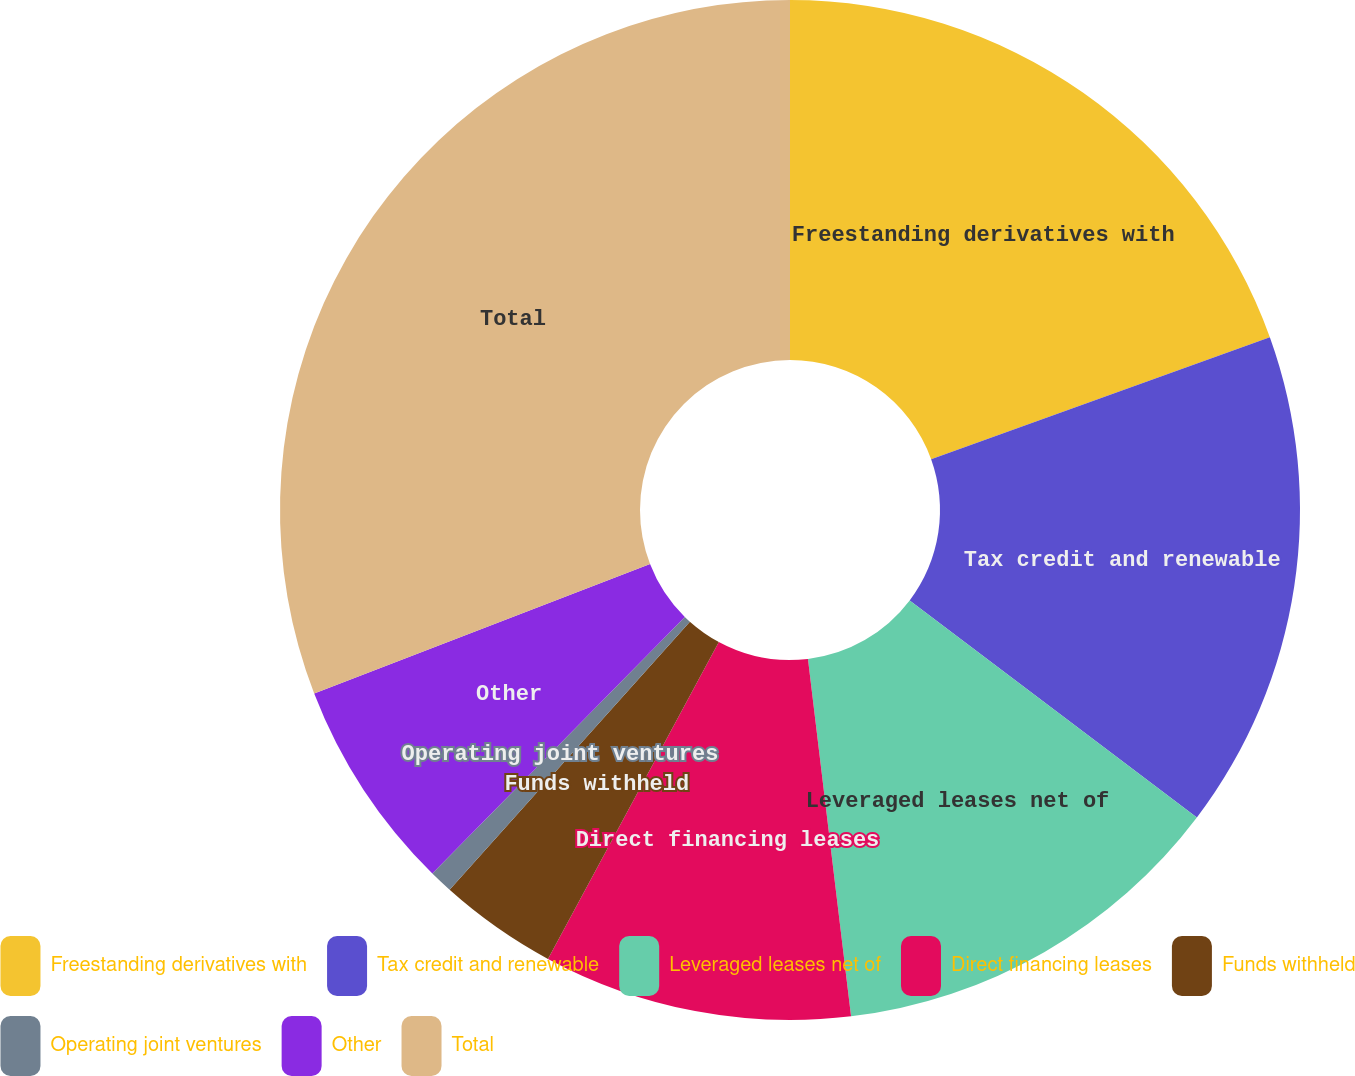<chart> <loc_0><loc_0><loc_500><loc_500><pie_chart><fcel>Freestanding derivatives with<fcel>Tax credit and renewable<fcel>Leveraged leases net of<fcel>Direct financing leases<fcel>Funds withheld<fcel>Operating joint ventures<fcel>Other<fcel>Total<nl><fcel>19.5%<fcel>15.8%<fcel>12.79%<fcel>9.78%<fcel>3.76%<fcel>0.74%<fcel>6.77%<fcel>30.86%<nl></chart> 